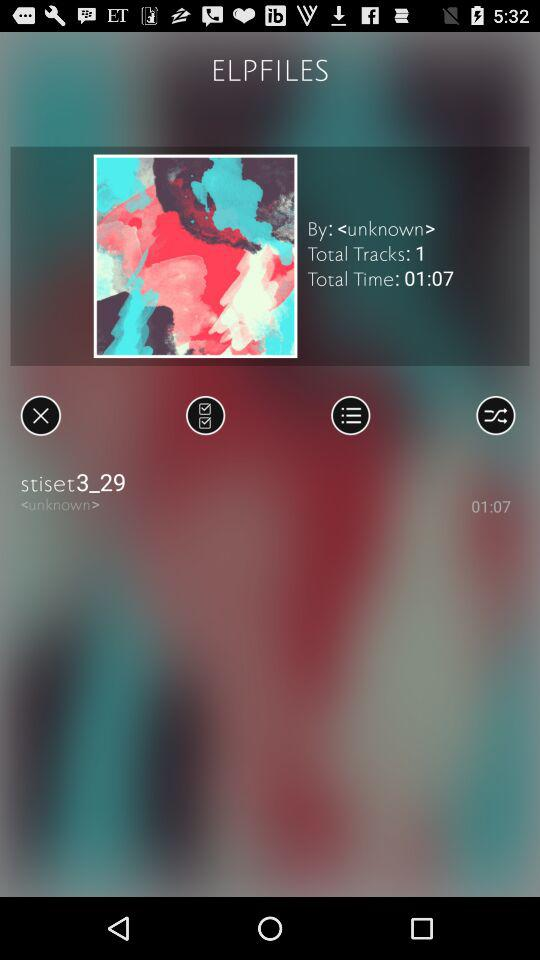How many tracks are in this album?
Answer the question using a single word or phrase. 1 